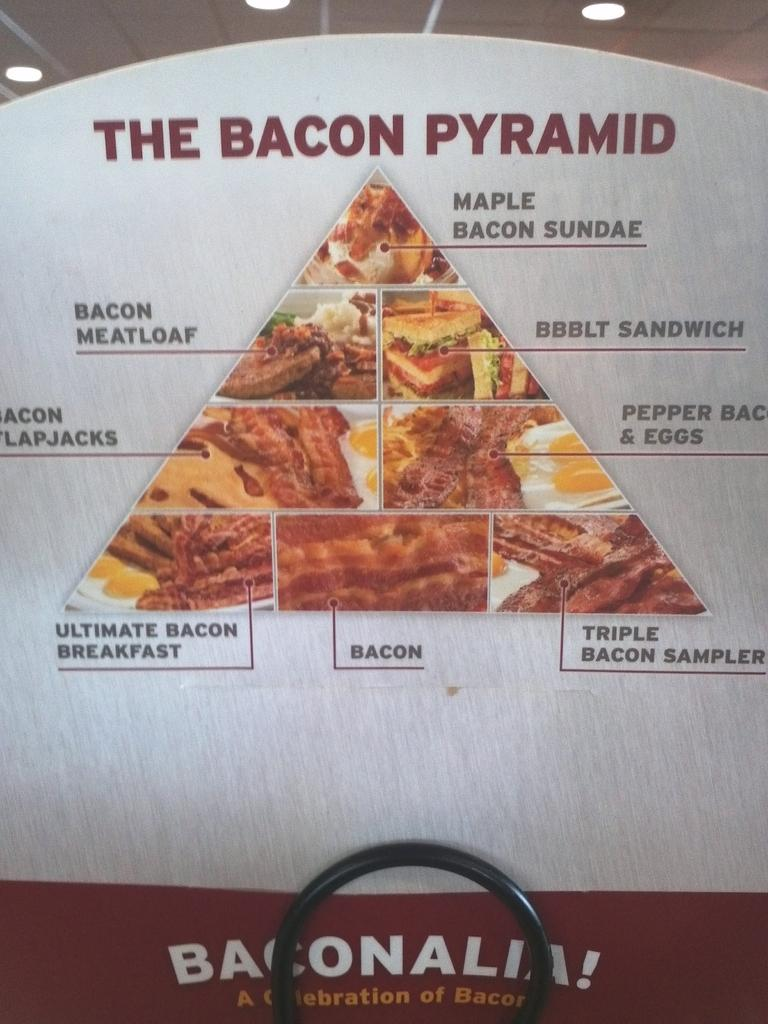What is featured in the image? There is a poster in the image. What can be found on the poster? There is text on the poster. What is located on the roof in the image? There are lights on the roof. What type of comfort can be found in the verse written on the poster? There is no verse or comfort mentioned in the image; it only features a poster with text and lights on the roof. 